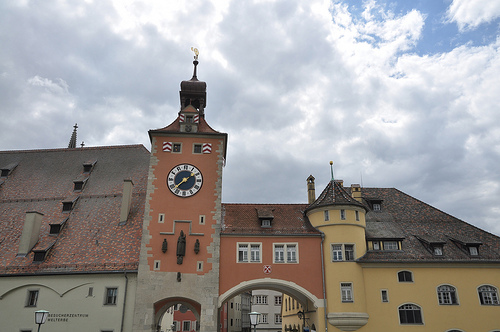Please provide a short description for this region: [0.86, 0.74, 0.92, 0.78]. This is a window on the building. 